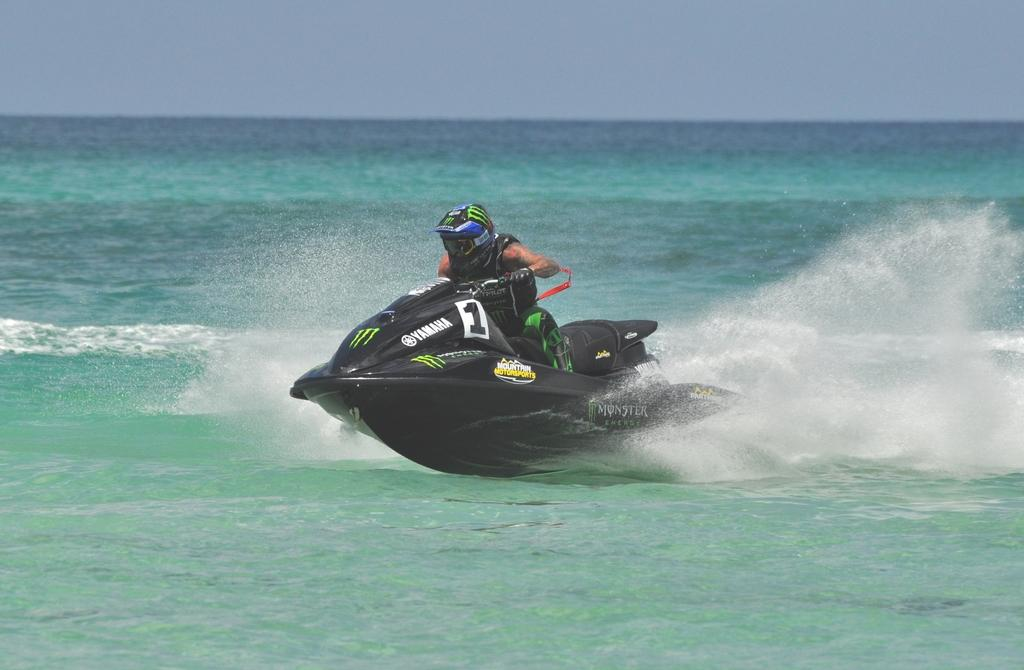Who is present in the image? There is a person in the image. What is the person wearing? The person is wearing a helmet. What activity is the person engaged in? The person is riding a jet ski. Where is the jet ski located? The jet ski is on the water. What can be seen in the background of the image? The sky is visible in the background of the image. What type of cable is being used to solve the riddle in the image? There is no cable or riddle present in the image; it features a person riding a jet ski on the water. 